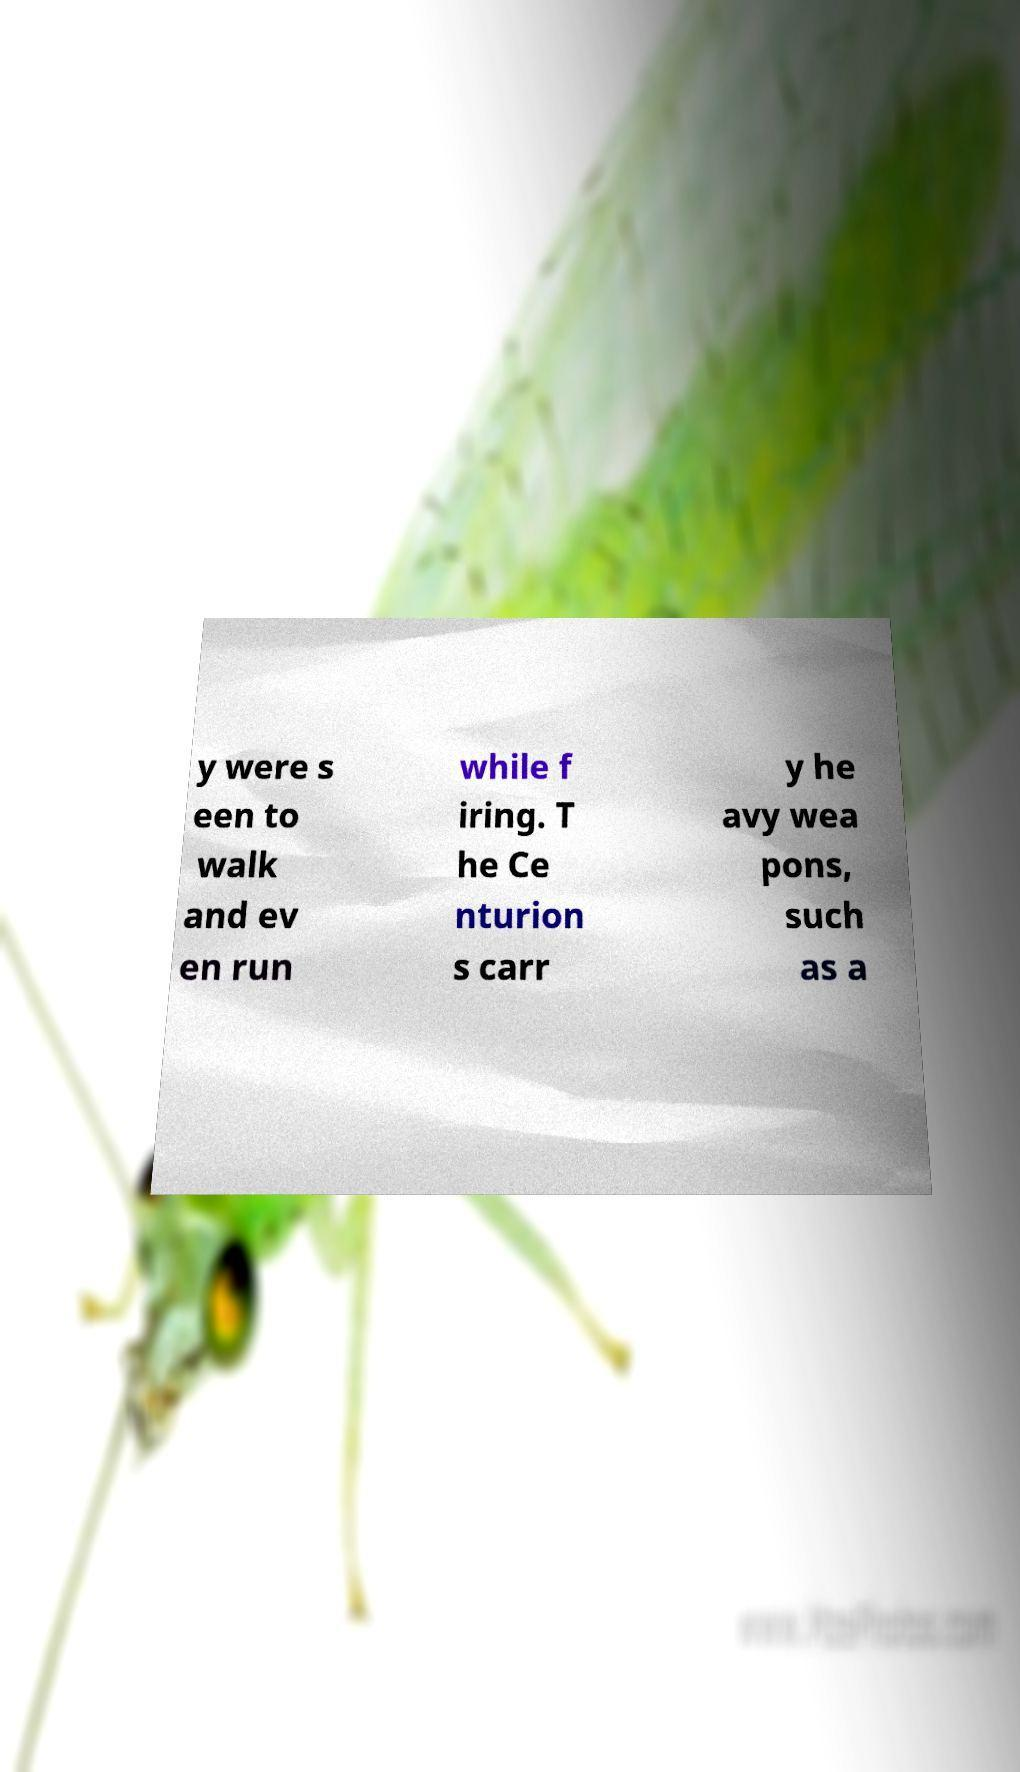Can you accurately transcribe the text from the provided image for me? y were s een to walk and ev en run while f iring. T he Ce nturion s carr y he avy wea pons, such as a 